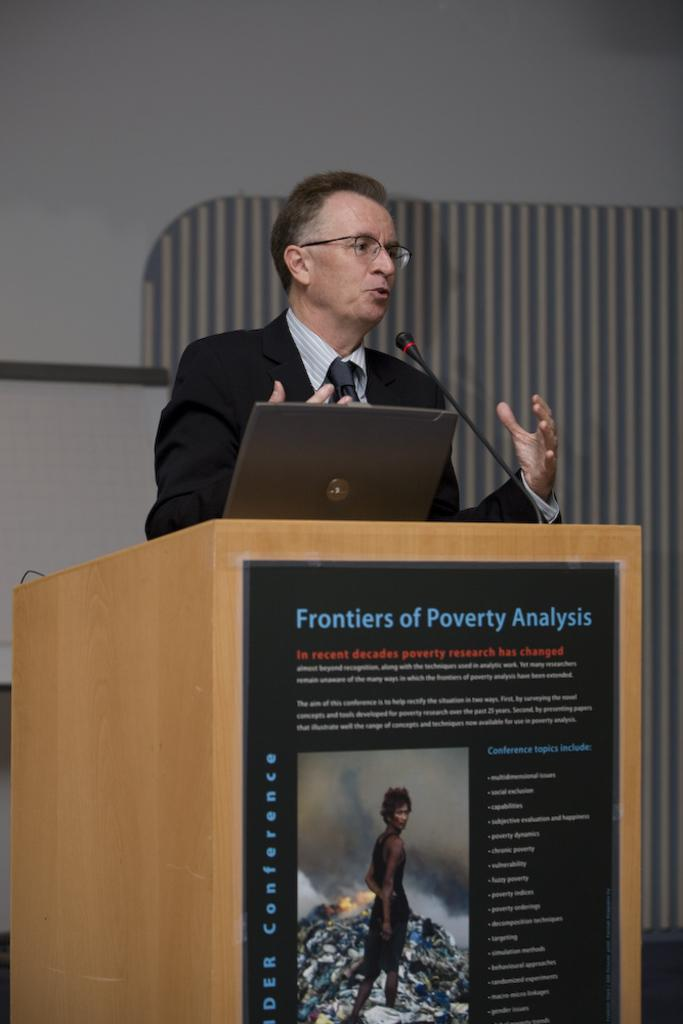<image>
Write a terse but informative summary of the picture. a man standing behind a stand with a poster on it that says 'frontiers of poverty analysis' 